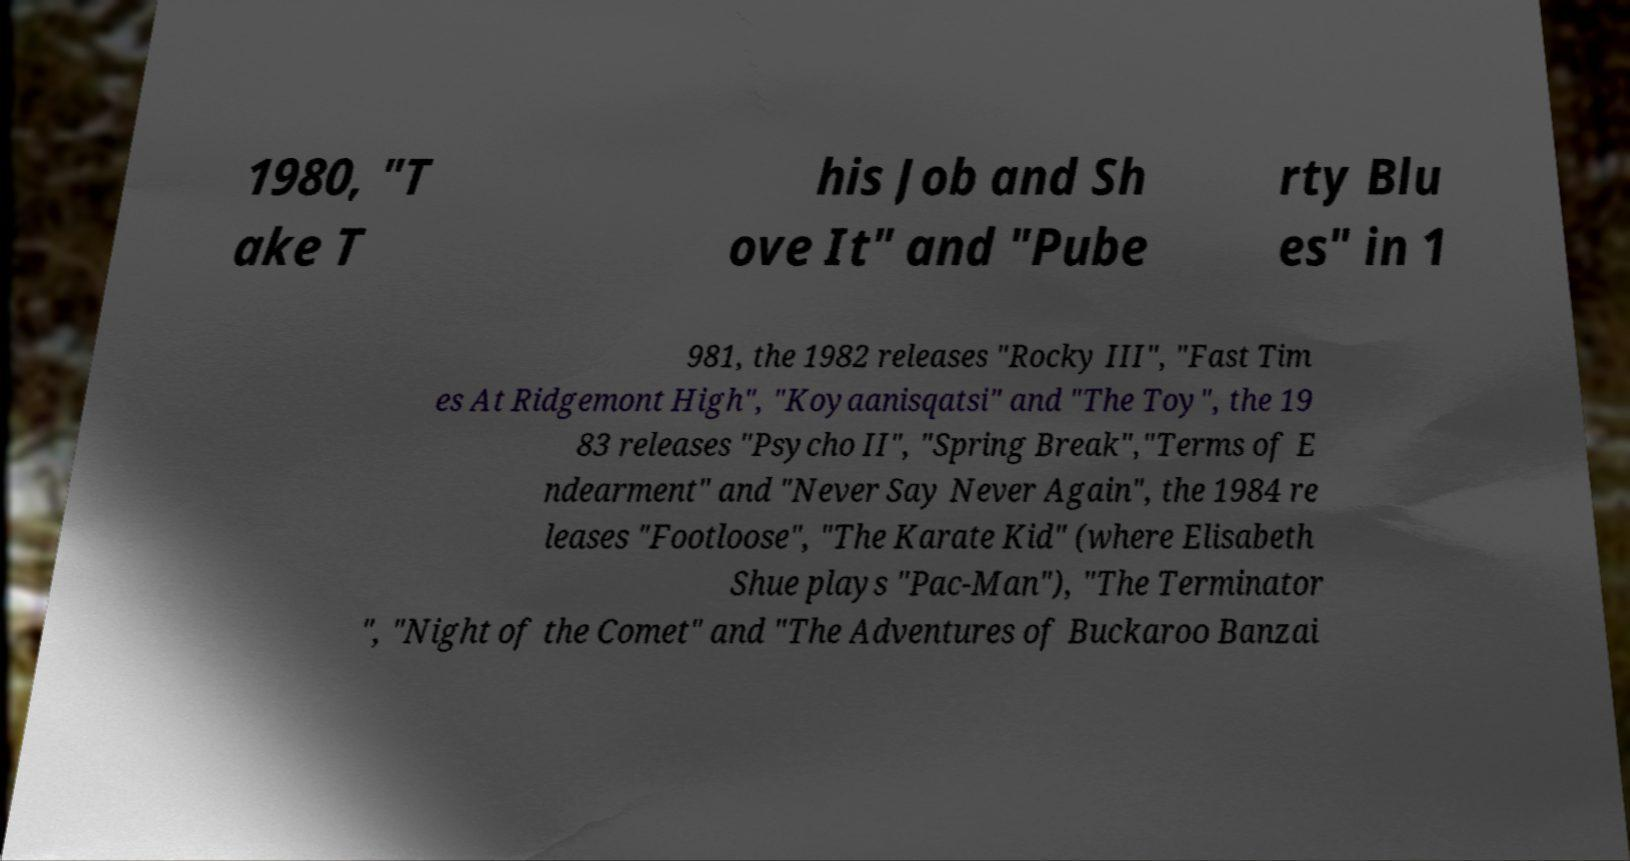What messages or text are displayed in this image? I need them in a readable, typed format. 1980, "T ake T his Job and Sh ove It" and "Pube rty Blu es" in 1 981, the 1982 releases "Rocky III", "Fast Tim es At Ridgemont High", "Koyaanisqatsi" and "The Toy", the 19 83 releases "Psycho II", "Spring Break","Terms of E ndearment" and "Never Say Never Again", the 1984 re leases "Footloose", "The Karate Kid" (where Elisabeth Shue plays "Pac-Man"), "The Terminator ", "Night of the Comet" and "The Adventures of Buckaroo Banzai 